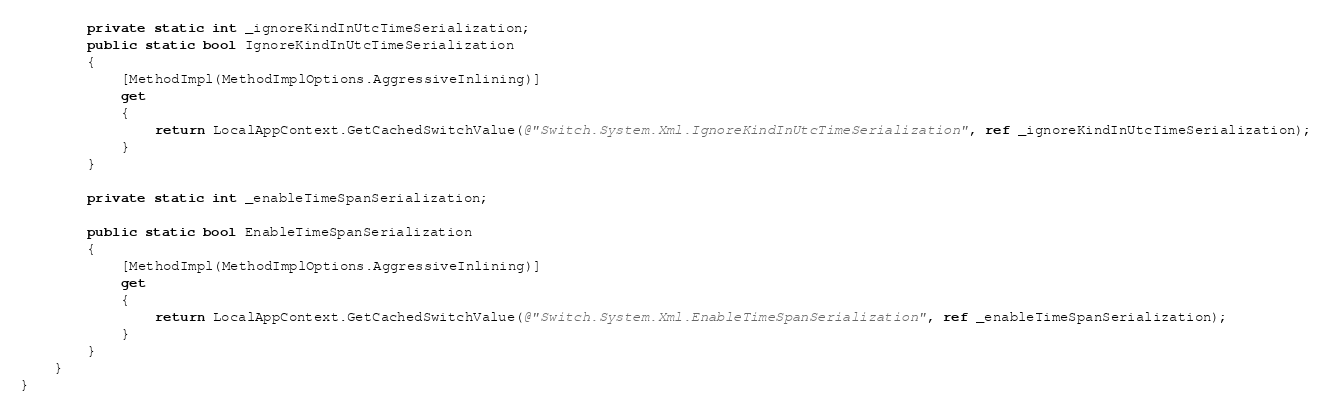<code> <loc_0><loc_0><loc_500><loc_500><_C#_>
        private static int _ignoreKindInUtcTimeSerialization;
        public static bool IgnoreKindInUtcTimeSerialization
        {
            [MethodImpl(MethodImplOptions.AggressiveInlining)]
            get
            {
                return LocalAppContext.GetCachedSwitchValue(@"Switch.System.Xml.IgnoreKindInUtcTimeSerialization", ref _ignoreKindInUtcTimeSerialization);
            }
        }

        private static int _enableTimeSpanSerialization;

        public static bool EnableTimeSpanSerialization
        {
            [MethodImpl(MethodImplOptions.AggressiveInlining)]
            get
            {
                return LocalAppContext.GetCachedSwitchValue(@"Switch.System.Xml.EnableTimeSpanSerialization", ref _enableTimeSpanSerialization);
            }
        }
    }
}
</code> 